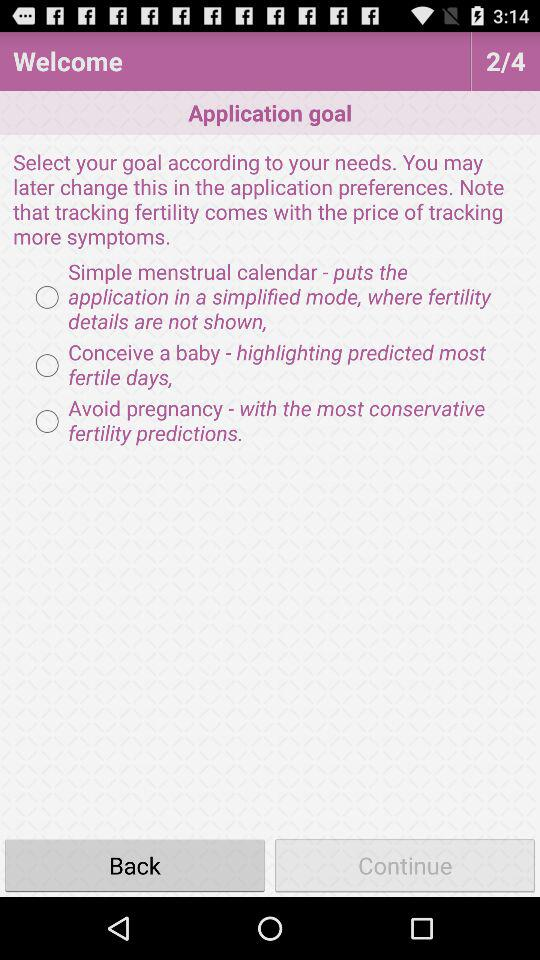What is the total number of pages? The total number of pages is 4. 